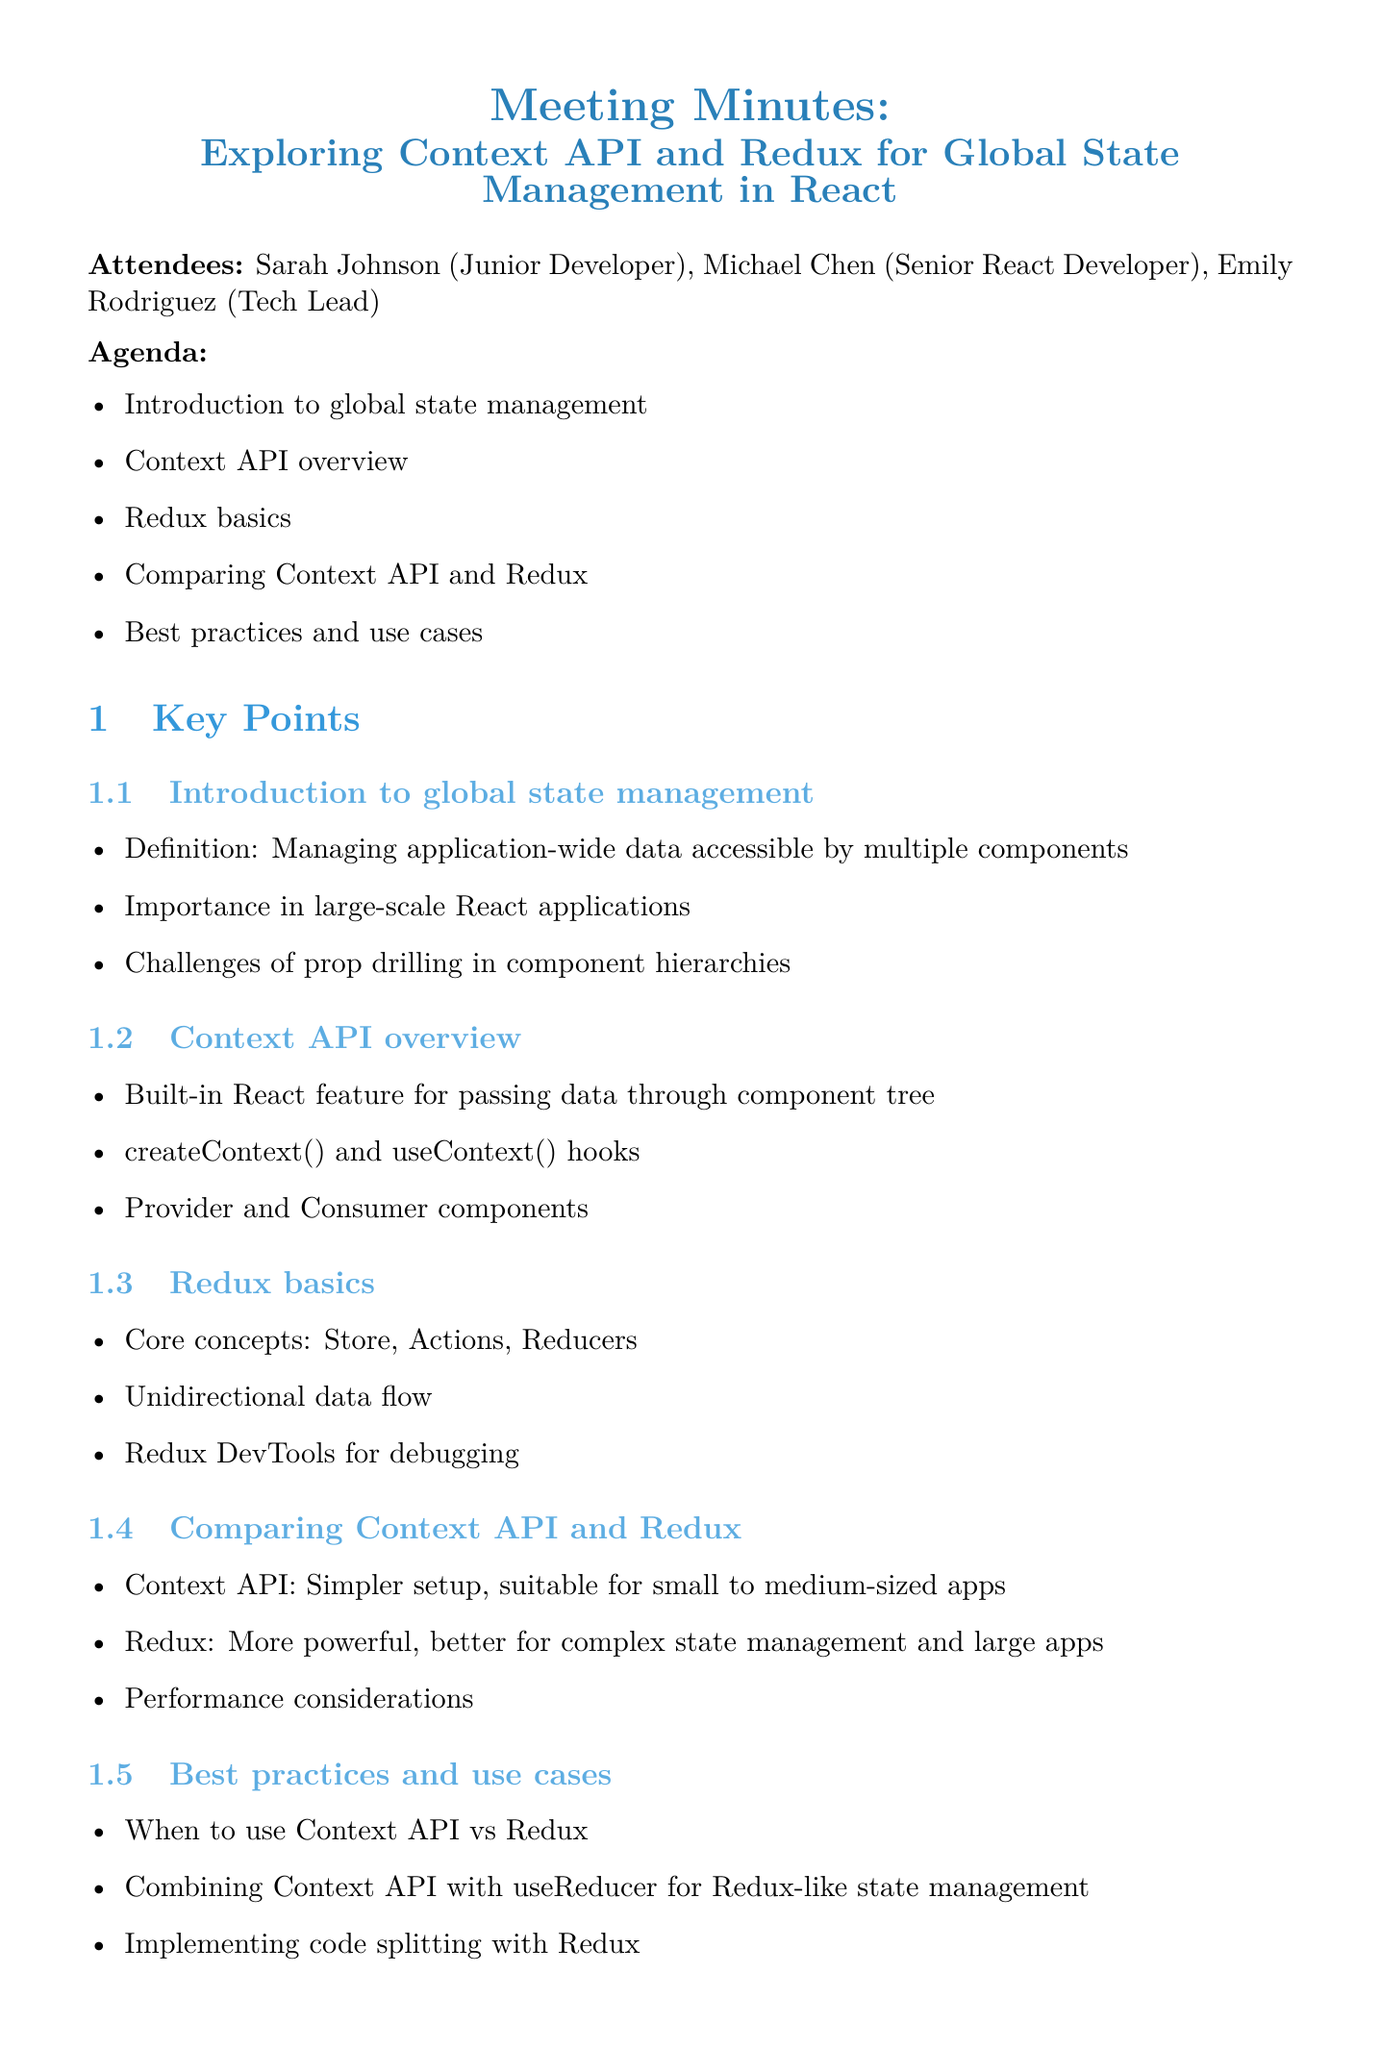What is the meeting title? The meeting title is stated at the beginning of the document, highlighting the main topic explored.
Answer: Exploring Context API and Redux for Global State Management in React Who is the Tech Lead? The document lists the attendees, including their roles, and identifies Emily Rodriguez as the Tech Lead.
Answer: Emily Rodriguez What is one key point about the Context API? The key points section outlines various details about the Context API, including its built-in nature in React for data passing.
Answer: Built-in React feature for passing data through component tree What is the core concept of Redux mentioned in the document? The document specifies the core concepts of Redux in its basics section, highlighting major elements.
Answer: Store When is Context API more suitable according to the document? The comparison section discusses the Context API's suitability for specific application sizes and complexities.
Answer: Small to medium-sized apps What is Sarah's action item? The action items list individual tasks assigned to attendees, specifying Sarah's task explicitly.
Answer: Complete React Context API tutorial on reactjs.org What is one resource provided in the document? The resources section details external links for further study related to the meeting content.
Answer: Official React Context documentation How many attendees are listed? The document specifies the number of attendees mentioned and their respective roles, providing a clear count.
Answer: Three Which hooks are associated with the Context API? The overview section of the Context API mentions specific hooks that are directly tied to its functionality.
Answer: createContext() and useContext() What is one best practice mentioned for using Redux? The best practices section includes guidance on when to use Redux, emphasizing effective strategies for state management.
Answer: Implementing code splitting with Redux 